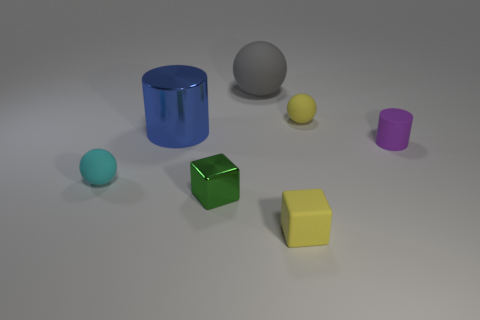Is there anything in the image that suggests what time of day it might be? The image doesn't provide explicit clues about the time of day, as it seems to be taken in a controlled indoor environment with consistent lighting that doesn't give away any specific time cues. Do the shadows tell us anything about the light source? Yes, the shadows are soft and extend to the right of the objects, indicating a light source to the left of the scene. This suggests a single diffuse light, consistent with an indoor photo setup. 